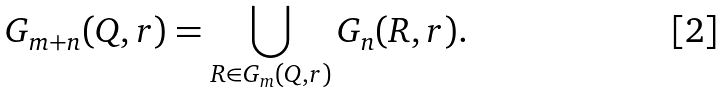<formula> <loc_0><loc_0><loc_500><loc_500>G _ { m + n } ( Q , r ) = \bigcup _ { R \in G _ { m } ( Q , r ) } G _ { n } ( R , r ) .</formula> 